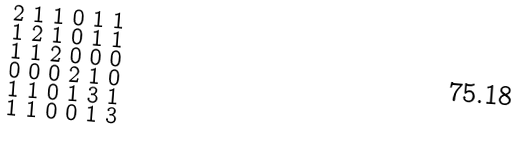Convert formula to latex. <formula><loc_0><loc_0><loc_500><loc_500>\begin{smallmatrix} 2 & 1 & 1 & 0 & 1 & 1 \\ 1 & 2 & 1 & 0 & 1 & 1 \\ 1 & 1 & 2 & 0 & 0 & 0 \\ 0 & 0 & 0 & 2 & 1 & 0 \\ 1 & 1 & 0 & 1 & 3 & 1 \\ 1 & 1 & 0 & 0 & 1 & 3 \end{smallmatrix}</formula> 